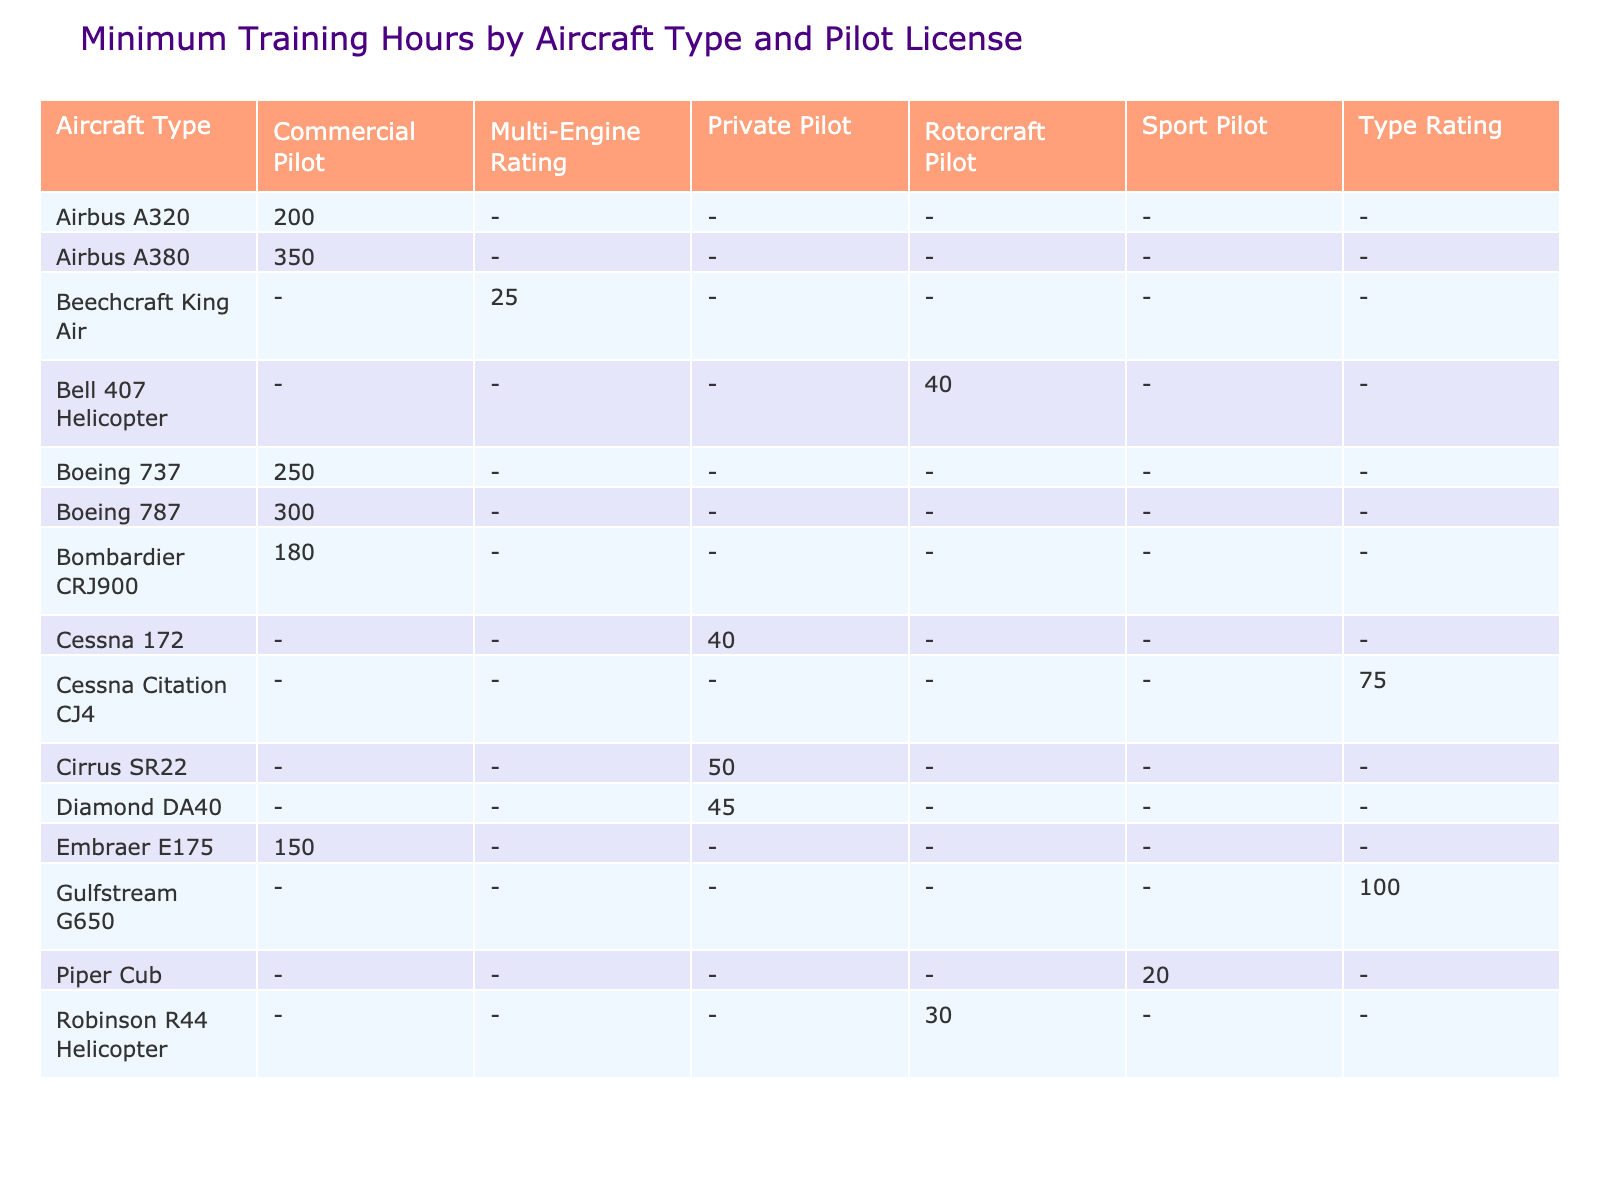What is the minimum training hours required for the Boeing 737? The table shows that the minimum training hours required for the Boeing 737 under the Commercial Pilot license is 250 hours.
Answer: 250 Is there any aircraft type listed that requires less than 100 training hours? By checking the minimum training hours for each aircraft type, I see that the Piper Cub requires only 20 hours. Therefore, yes, there is an aircraft that requires less than 100 training hours.
Answer: Yes Which aircraft type requires the most training hours? According to the table, the Airbus A380 requires the most training hours, which is 350.
Answer: Airbus A380 How many aircraft types require Commercial Pilot licenses? The table lists several aircraft types with the Commercial Pilot license: Boeing 737, Airbus A320, Embraer E175, Bombardier CRJ900, Boeing 787, and Airbus A380. Counting these, I find there are six aircraft types that require a Commercial Pilot license.
Answer: 6 What is the average minimum training hours for Private Pilot licensed aircraft? The Private Pilot licensed aircraft in the table are Cessna 172 (40), Cirrus SR22 (50), and Diamond DA40 (45). To find the average, I add the training hours (40 + 50 + 45 = 135) and divide by the number of aircraft (3). Therefore, the average is 135/3 = 45.
Answer: 45 Are there any rotorcraft pilots that require more than 30 training hours? The table shows that both the Bell 407 Helicopter and the Robinson R44 Helicopter are categorized as rotorcraft pilots. Bell 407 requires 40 hours, which is more than 30 hours. Therefore, yes, there are rotorcraft pilots that require more than 30 training hours.
Answer: Yes How many training hours are required for a Type Rating license? From the table, I see there are two aircraft types that require a Type Rating: Gulfstream G650 (100 hours) and Cessna Citation CJ4 (75 hours). Summing these gives me a range of 75-100 hours.
Answer: 75-100 If a pilot wants to fly a Multi-Engine Rating aircraft, what is the minimum training hours needed? The only aircraft type listed for Multi-Engine Rating is Beechcraft King Air, which requires 25 hours of training.
Answer: 25 Is the age group for training hours consistent for a specific aircraft? Looking at the table, I can see that the age group for Beechcraft King Air, Piper Cub, Bell 407 Helicopter, and Cirrus SR22 is consistent at 12-17 years. Therefore, the age group is consistent for this subset of aircraft.
Answer: Yes 